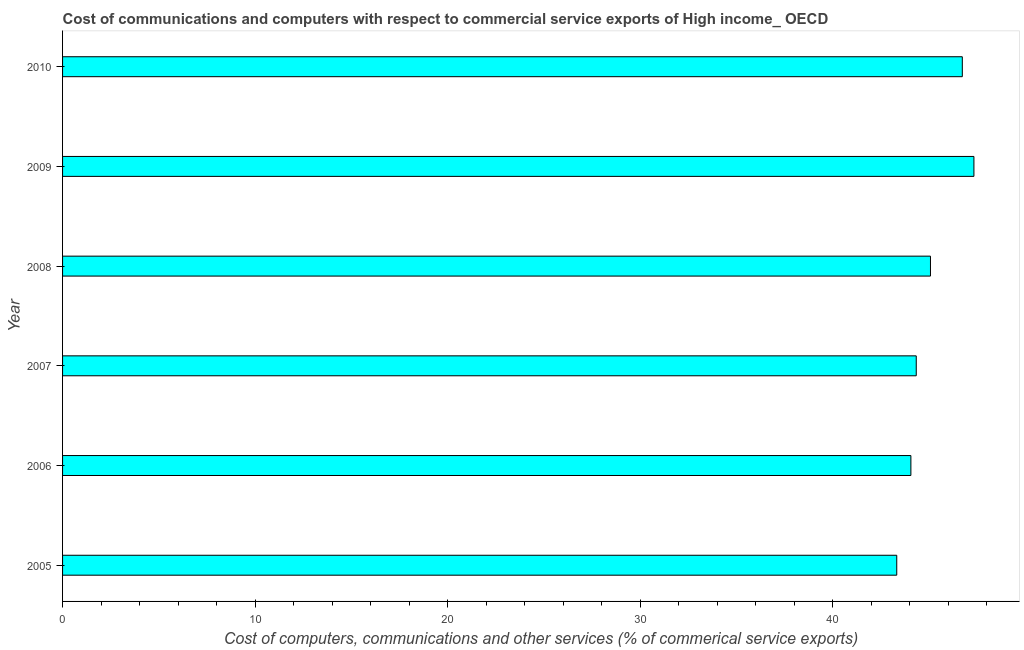Does the graph contain grids?
Your answer should be compact. No. What is the title of the graph?
Make the answer very short. Cost of communications and computers with respect to commercial service exports of High income_ OECD. What is the label or title of the X-axis?
Provide a succinct answer. Cost of computers, communications and other services (% of commerical service exports). What is the cost of communications in 2005?
Offer a very short reply. 43.34. Across all years, what is the maximum cost of communications?
Ensure brevity in your answer.  47.35. Across all years, what is the minimum  computer and other services?
Your answer should be compact. 43.34. In which year was the  computer and other services maximum?
Offer a very short reply. 2009. What is the sum of the  computer and other services?
Make the answer very short. 270.94. What is the difference between the cost of communications in 2007 and 2010?
Your answer should be very brief. -2.39. What is the average cost of communications per year?
Give a very brief answer. 45.16. What is the median  computer and other services?
Provide a short and direct response. 44.72. In how many years, is the  computer and other services greater than 22 %?
Ensure brevity in your answer.  6. Do a majority of the years between 2009 and 2010 (inclusive) have cost of communications greater than 8 %?
Offer a terse response. Yes. What is the difference between the highest and the second highest cost of communications?
Ensure brevity in your answer.  0.6. What is the difference between the highest and the lowest  computer and other services?
Keep it short and to the point. 4.01. How many years are there in the graph?
Offer a very short reply. 6. What is the difference between two consecutive major ticks on the X-axis?
Offer a very short reply. 10. Are the values on the major ticks of X-axis written in scientific E-notation?
Offer a very short reply. No. What is the Cost of computers, communications and other services (% of commerical service exports) of 2005?
Ensure brevity in your answer.  43.34. What is the Cost of computers, communications and other services (% of commerical service exports) of 2006?
Offer a very short reply. 44.07. What is the Cost of computers, communications and other services (% of commerical service exports) in 2007?
Your answer should be very brief. 44.35. What is the Cost of computers, communications and other services (% of commerical service exports) of 2008?
Provide a short and direct response. 45.09. What is the Cost of computers, communications and other services (% of commerical service exports) of 2009?
Give a very brief answer. 47.35. What is the Cost of computers, communications and other services (% of commerical service exports) of 2010?
Your answer should be compact. 46.74. What is the difference between the Cost of computers, communications and other services (% of commerical service exports) in 2005 and 2006?
Offer a very short reply. -0.74. What is the difference between the Cost of computers, communications and other services (% of commerical service exports) in 2005 and 2007?
Your answer should be compact. -1.01. What is the difference between the Cost of computers, communications and other services (% of commerical service exports) in 2005 and 2008?
Provide a short and direct response. -1.75. What is the difference between the Cost of computers, communications and other services (% of commerical service exports) in 2005 and 2009?
Give a very brief answer. -4.01. What is the difference between the Cost of computers, communications and other services (% of commerical service exports) in 2005 and 2010?
Provide a short and direct response. -3.41. What is the difference between the Cost of computers, communications and other services (% of commerical service exports) in 2006 and 2007?
Make the answer very short. -0.28. What is the difference between the Cost of computers, communications and other services (% of commerical service exports) in 2006 and 2008?
Ensure brevity in your answer.  -1.02. What is the difference between the Cost of computers, communications and other services (% of commerical service exports) in 2006 and 2009?
Give a very brief answer. -3.27. What is the difference between the Cost of computers, communications and other services (% of commerical service exports) in 2006 and 2010?
Offer a terse response. -2.67. What is the difference between the Cost of computers, communications and other services (% of commerical service exports) in 2007 and 2008?
Ensure brevity in your answer.  -0.74. What is the difference between the Cost of computers, communications and other services (% of commerical service exports) in 2007 and 2009?
Your answer should be compact. -3. What is the difference between the Cost of computers, communications and other services (% of commerical service exports) in 2007 and 2010?
Keep it short and to the point. -2.39. What is the difference between the Cost of computers, communications and other services (% of commerical service exports) in 2008 and 2009?
Keep it short and to the point. -2.26. What is the difference between the Cost of computers, communications and other services (% of commerical service exports) in 2008 and 2010?
Make the answer very short. -1.65. What is the difference between the Cost of computers, communications and other services (% of commerical service exports) in 2009 and 2010?
Provide a succinct answer. 0.6. What is the ratio of the Cost of computers, communications and other services (% of commerical service exports) in 2005 to that in 2006?
Provide a short and direct response. 0.98. What is the ratio of the Cost of computers, communications and other services (% of commerical service exports) in 2005 to that in 2009?
Your answer should be compact. 0.92. What is the ratio of the Cost of computers, communications and other services (% of commerical service exports) in 2005 to that in 2010?
Keep it short and to the point. 0.93. What is the ratio of the Cost of computers, communications and other services (% of commerical service exports) in 2006 to that in 2008?
Offer a very short reply. 0.98. What is the ratio of the Cost of computers, communications and other services (% of commerical service exports) in 2006 to that in 2010?
Give a very brief answer. 0.94. What is the ratio of the Cost of computers, communications and other services (% of commerical service exports) in 2007 to that in 2008?
Ensure brevity in your answer.  0.98. What is the ratio of the Cost of computers, communications and other services (% of commerical service exports) in 2007 to that in 2009?
Your answer should be very brief. 0.94. What is the ratio of the Cost of computers, communications and other services (% of commerical service exports) in 2007 to that in 2010?
Offer a terse response. 0.95. What is the ratio of the Cost of computers, communications and other services (% of commerical service exports) in 2008 to that in 2009?
Offer a terse response. 0.95. 